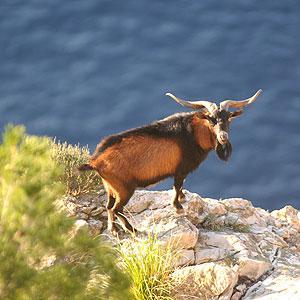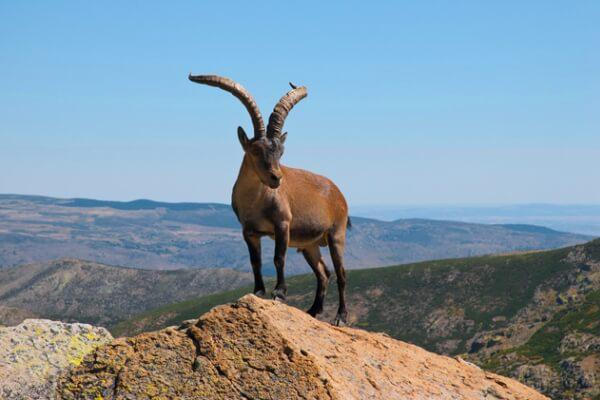The first image is the image on the left, the second image is the image on the right. Examine the images to the left and right. Is the description "There are more than two animals." accurate? Answer yes or no. No. 